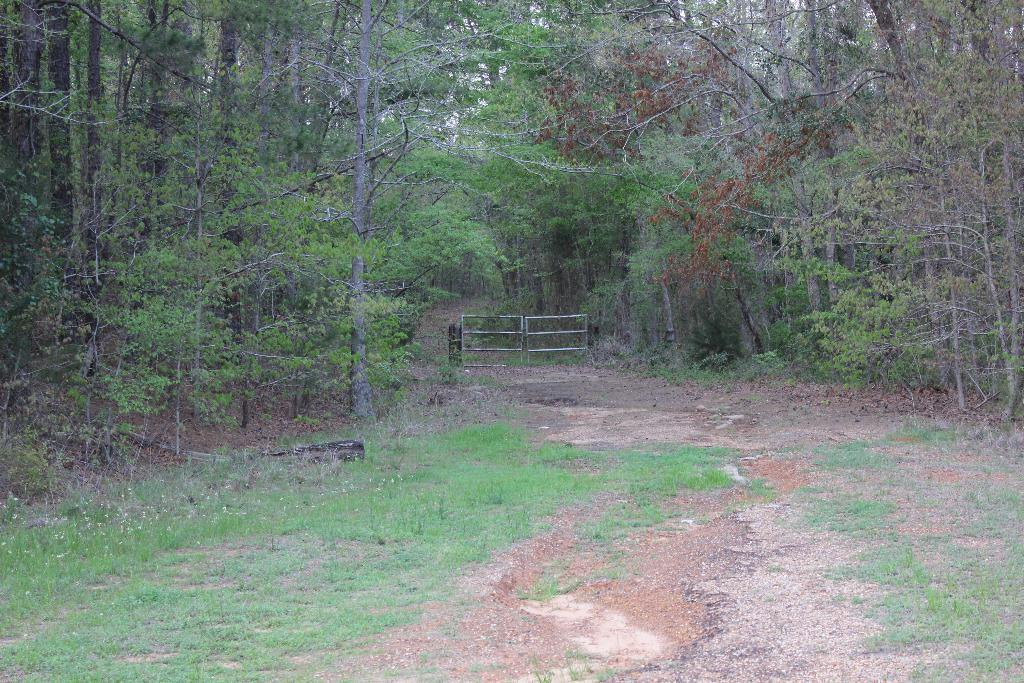What type of vegetation can be seen in the image? There are trees in the image. What structure is present in the image? There is a gate in the image. What is visible at the top of the image? The sky is visible at the top of the image. What type of ground cover is present in the image? There is grass in the image. What part of the natural environment is visible in the image? The ground is visible in the image. What type of pipe is visible in the image? There is no pipe present in the image. What arithmetic problem is being solved in the image? There is no arithmetic problem present in the image. 